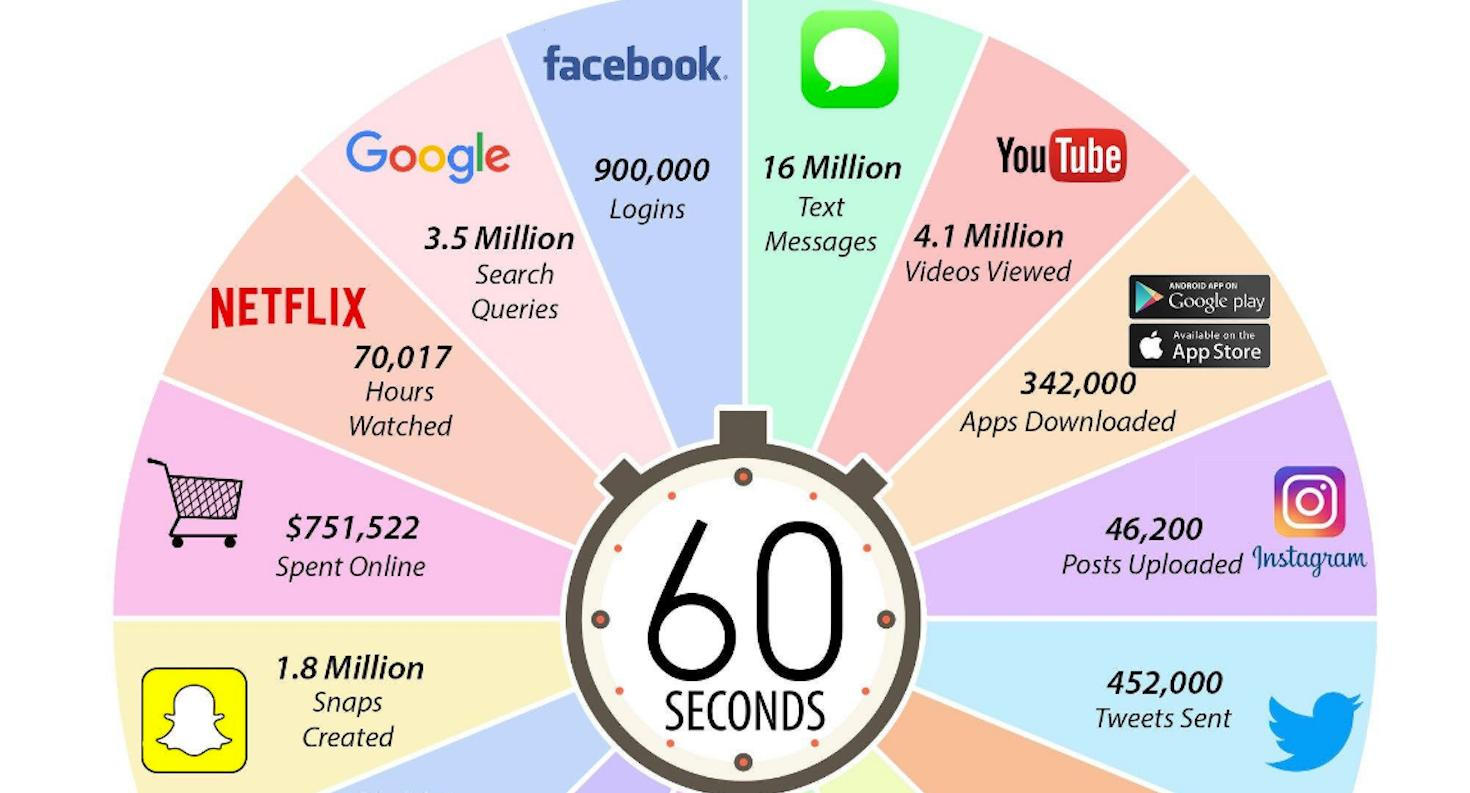Mention a couple of crucial points in this snapshot. There are two sources from which apps can be downloaded: Google Play and the App Store. Google processes approximately 3.5 million queries in 60 seconds. 